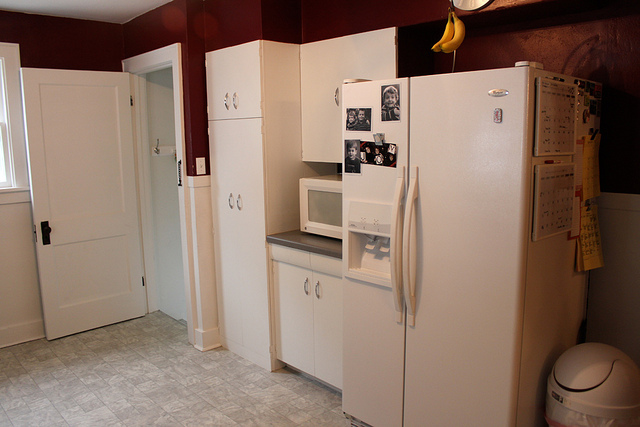What kind of appliances can be seen in this kitchen? The kitchen includes a refrigerator, a microwave, an oven with a stovetop, and what appears to be a dishwasher built into the cabinetry. 